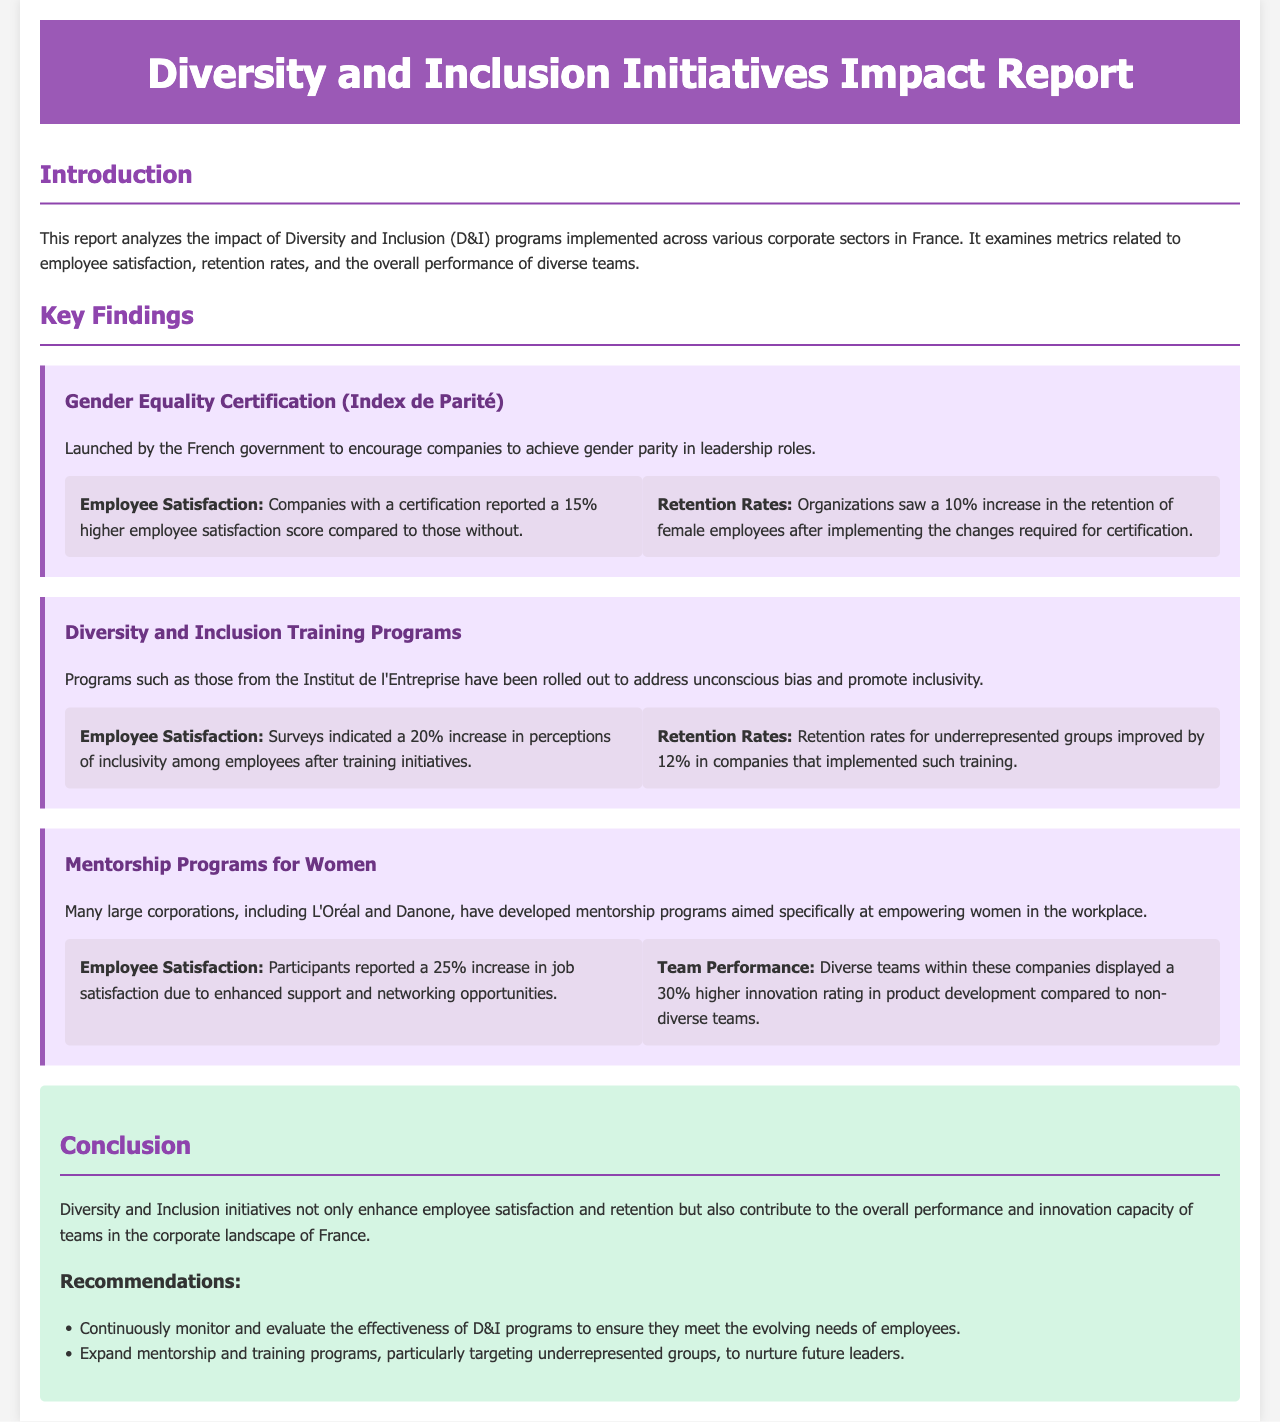what is the title of the report? The title of the report is stated in the header section of the document, which is "Diversity and Inclusion Initiatives Impact Report."
Answer: Diversity and Inclusion Initiatives Impact Report what is the primary focus of the report? The report primarily focuses on analyzing the impact of diversity and inclusion programs in corporate settings in France, covering employee satisfaction, retention rates, and team performance.
Answer: impact of diversity and inclusion programs what percentage increase in employee satisfaction was reported for Gender Equality Certification? The report states that certified companies reported a 15% higher employee satisfaction score.
Answer: 15% how much did retention rates improve for underrepresented groups after training programs? The retention rates for underrepresented groups improved by 12% in companies that implemented such training.
Answer: 12% which companies developed mentorship programs for women? The report mentions that L'Oréal and Danone developed mentorship programs aimed at empowering women in the workplace.
Answer: L'Oréal and Danone what is the increase in job satisfaction reported by participants of the mentorship programs? Participants of the mentorship programs reported a 25% increase in job satisfaction due to enhanced support and networking opportunities.
Answer: 25% how much higher was the innovation rating of diverse teams in product development? Diverse teams displayed a 30% higher innovation rating in product development compared to non-diverse teams.
Answer: 30% what are two recommendations made in the report? The recommendations include continuously monitoring D&I programs and expanding mentorship and training programs for underrepresented groups.
Answer: monitor D&I programs; expand mentorship and training what is the impact of D&I initiatives on employee retention according to the report? The report indicates that D&I initiatives contribute to enhancing employee retention, with specific metrics stating improvements in retention rates following D&I program implementation.
Answer: enhance employee retention 